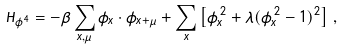<formula> <loc_0><loc_0><loc_500><loc_500>H _ { \phi ^ { 4 } } = - \beta \sum _ { x , \mu } \vec { \phi } _ { x } \cdot \vec { \phi } _ { x + \hat { \mu } } + \sum _ { x } \left [ \vec { \phi } _ { x } ^ { \, 2 } + \lambda ( \vec { \phi } _ { x } ^ { \, 2 } - 1 ) ^ { 2 } \right ] \, ,</formula> 